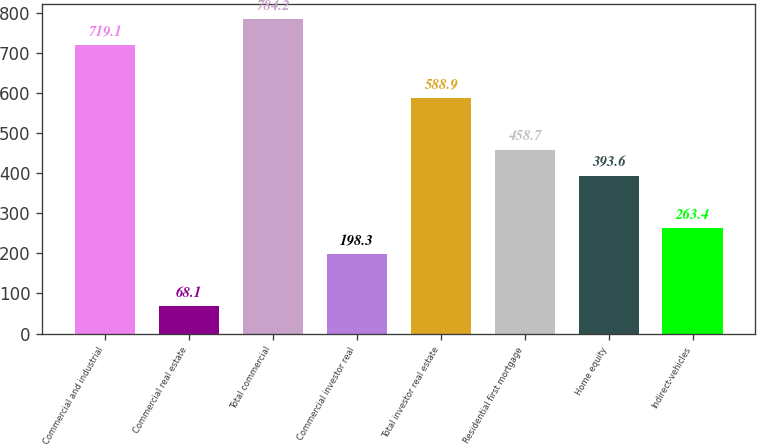Convert chart to OTSL. <chart><loc_0><loc_0><loc_500><loc_500><bar_chart><fcel>Commercial and industrial<fcel>Commercial real estate<fcel>Total commercial<fcel>Commercial investor real<fcel>Total investor real estate<fcel>Residential first mortgage<fcel>Home equity<fcel>Indirect-vehicles<nl><fcel>719.1<fcel>68.1<fcel>784.2<fcel>198.3<fcel>588.9<fcel>458.7<fcel>393.6<fcel>263.4<nl></chart> 